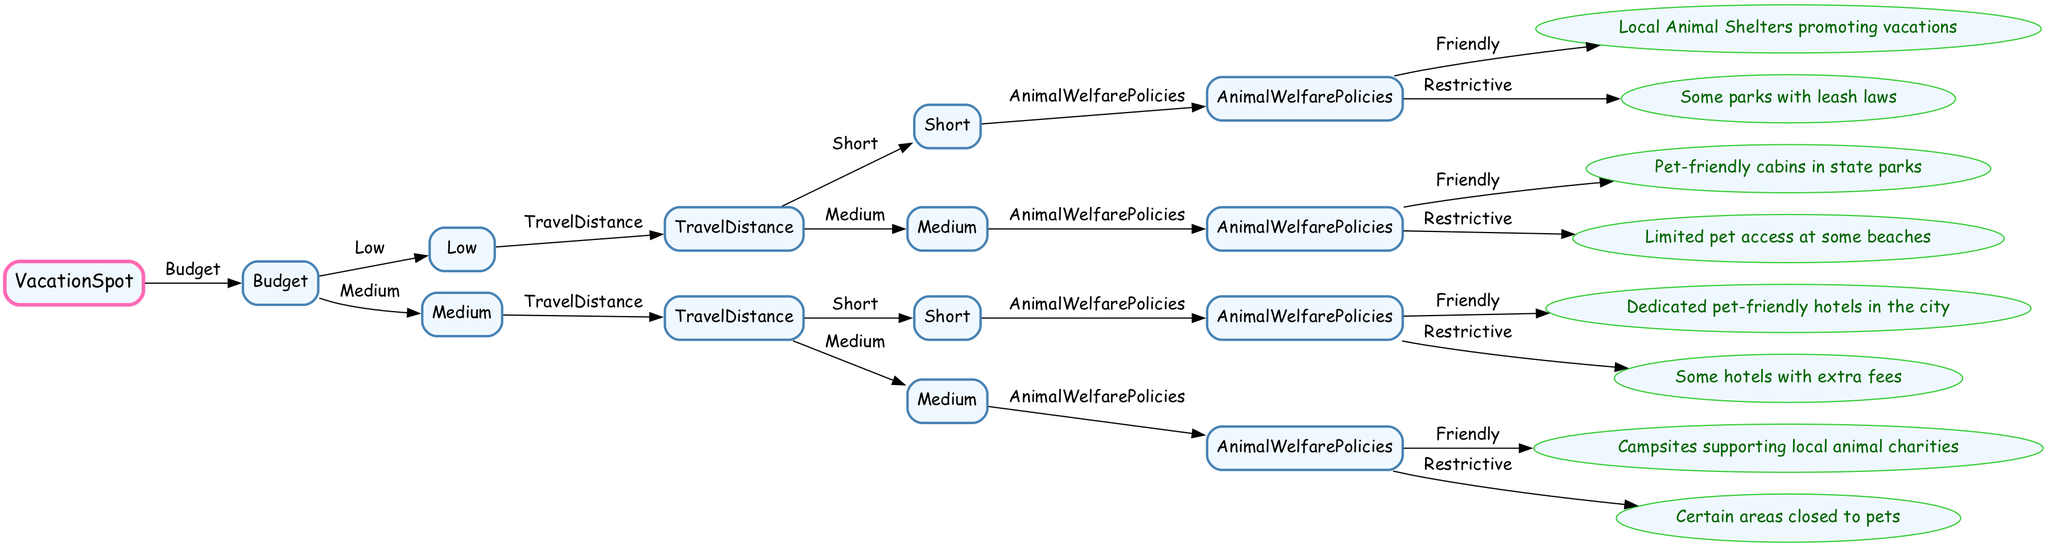What is the main decision criteria for determining vacation spots? The main decision criteria for determining vacation spots are Budget, Travel Distance, and Animal Welfare Policies, as these are the primary branches that guide the decision-making in the tree.
Answer: Budget, Travel Distance, Animal Welfare Policies How many nodes are there in the tree? The tree consists of 10 nodes, counting the root node and all the subsequent decision nodes leading to the final outcomes.
Answer: 10 What outcome is reached with a Low budget, Short travel distance, and Restrictive animal welfare policies? Following the path from Low budget, we see that Short travel distance leads to Animal Welfare Policies, where Restrictive indicates there are some parks with leash laws.
Answer: Some parks with leash laws What type of accommodations are available for a Medium budget, Medium travel distance, and Friendly animal welfare policies? For a Medium budget and Medium travel distance, the tree directs to Campsites that support local animal charities as the friendly option.
Answer: Campsites supporting local animal charities Which travel distance option is available for Low budget with Medium travel distance? For Low budget, if we take the Medium travel distance route in the tree, we see that the corresponding option available is Limited pet access at some beaches.
Answer: Limited pet access at some beaches If I choose a Medium budget and Short travel distance, what will be the potential restriction at hotels? Following the path for Medium budget and then Short travel distance indicates that the pet-friendly hotels in the city may have extra fees as a potential restriction.
Answer: Some hotels with extra fees What happens at the last level of the tree? At the last level of the tree, the outcomes provide information about specific vacation options based on the prior decisions regarding Budget, Travel Distance, and Animal Welfare Policies.
Answer: Specific vacation options How does a Low budget impact the choice of Travel Distance? A Low budget impacts the choice of Travel Distance by selecting between Short and Medium options, where the specific outcomes differ based on the Animal Welfare Policies associated with each distance.
Answer: Selects between Short and Medium What is the first decision point in the tree? The first decision point in the tree is the Budget, as it is the root node that leads to subsequent decisions regarding Travel Distance and Animal Welfare Policies.
Answer: Budget 